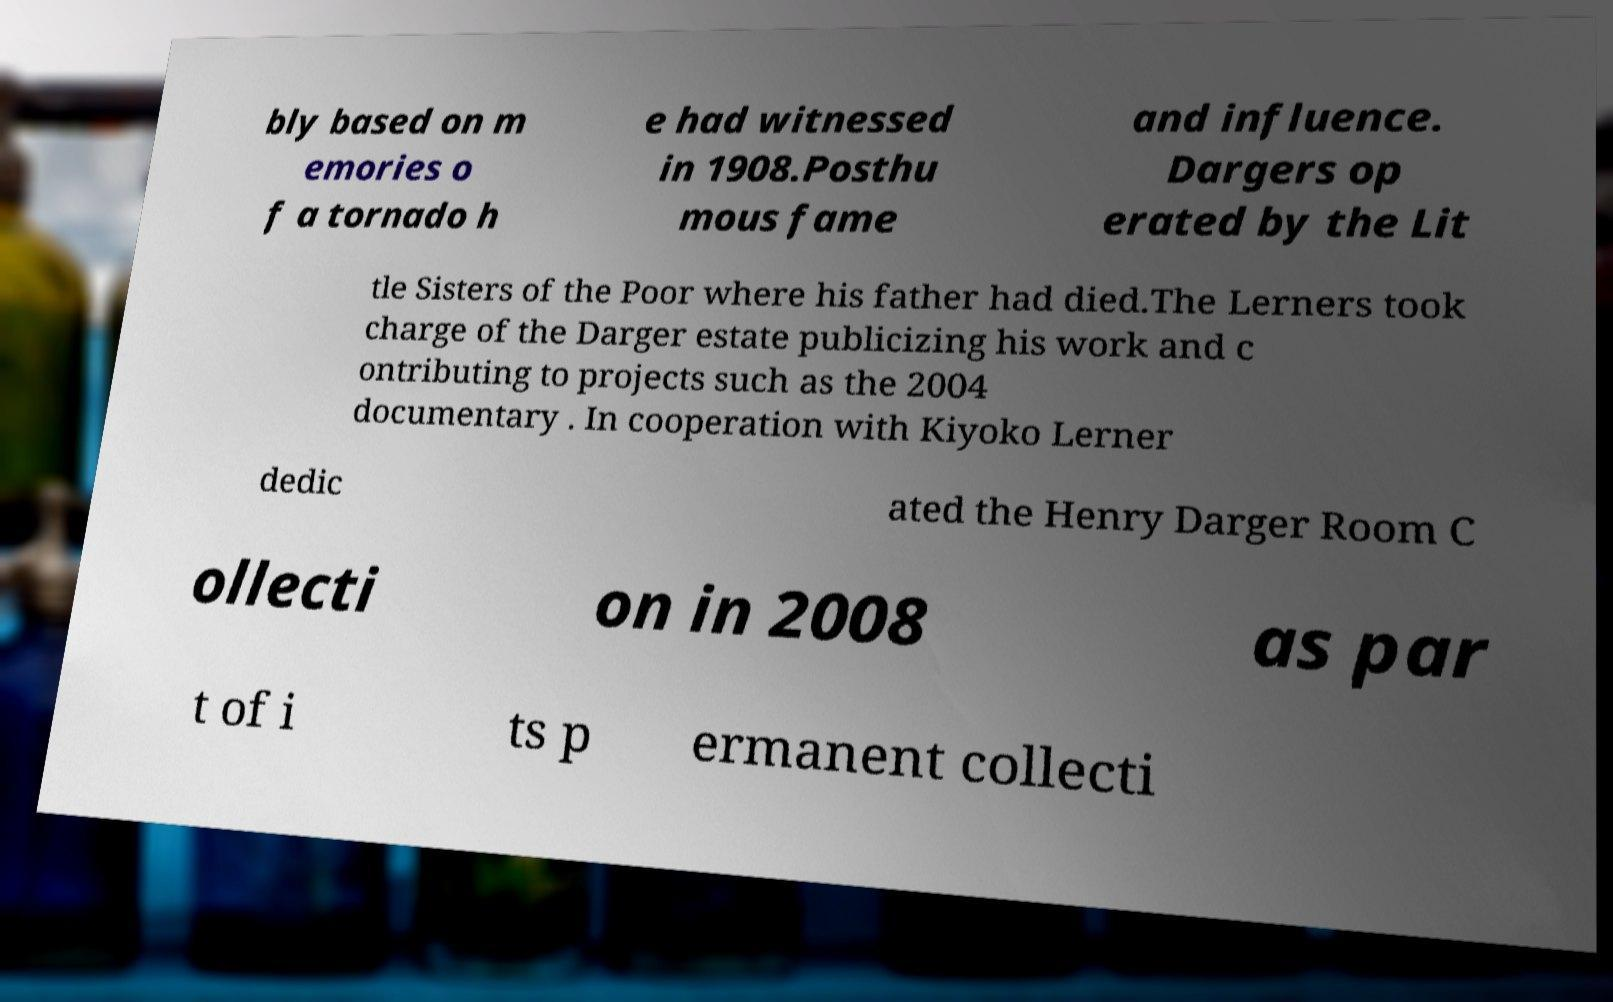There's text embedded in this image that I need extracted. Can you transcribe it verbatim? bly based on m emories o f a tornado h e had witnessed in 1908.Posthu mous fame and influence. Dargers op erated by the Lit tle Sisters of the Poor where his father had died.The Lerners took charge of the Darger estate publicizing his work and c ontributing to projects such as the 2004 documentary . In cooperation with Kiyoko Lerner dedic ated the Henry Darger Room C ollecti on in 2008 as par t of i ts p ermanent collecti 